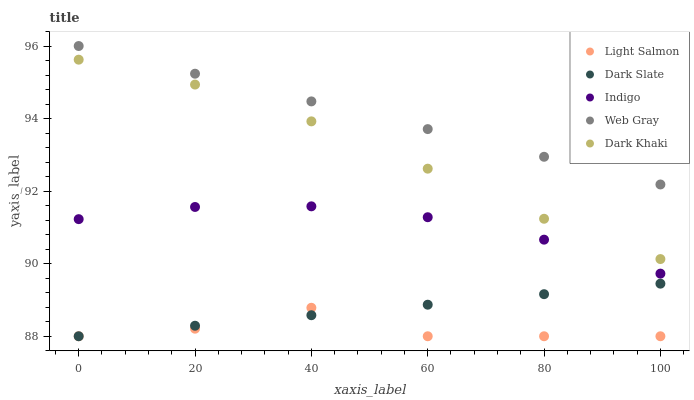Does Light Salmon have the minimum area under the curve?
Answer yes or no. Yes. Does Web Gray have the maximum area under the curve?
Answer yes or no. Yes. Does Dark Slate have the minimum area under the curve?
Answer yes or no. No. Does Dark Slate have the maximum area under the curve?
Answer yes or no. No. Is Web Gray the smoothest?
Answer yes or no. Yes. Is Light Salmon the roughest?
Answer yes or no. Yes. Is Dark Slate the smoothest?
Answer yes or no. No. Is Dark Slate the roughest?
Answer yes or no. No. Does Dark Slate have the lowest value?
Answer yes or no. Yes. Does Web Gray have the lowest value?
Answer yes or no. No. Does Web Gray have the highest value?
Answer yes or no. Yes. Does Dark Slate have the highest value?
Answer yes or no. No. Is Dark Khaki less than Web Gray?
Answer yes or no. Yes. Is Web Gray greater than Dark Khaki?
Answer yes or no. Yes. Does Dark Slate intersect Light Salmon?
Answer yes or no. Yes. Is Dark Slate less than Light Salmon?
Answer yes or no. No. Is Dark Slate greater than Light Salmon?
Answer yes or no. No. Does Dark Khaki intersect Web Gray?
Answer yes or no. No. 